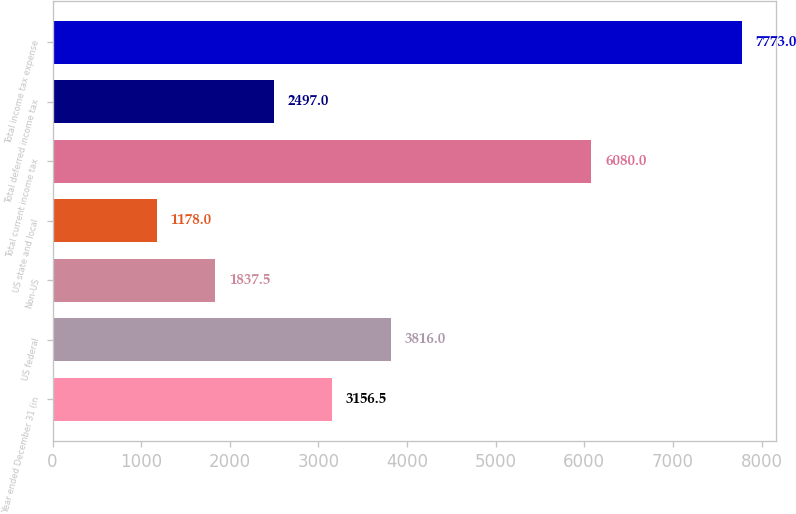<chart> <loc_0><loc_0><loc_500><loc_500><bar_chart><fcel>Year ended December 31 (in<fcel>US federal<fcel>Non-US<fcel>US state and local<fcel>Total current income tax<fcel>Total deferred income tax<fcel>Total income tax expense<nl><fcel>3156.5<fcel>3816<fcel>1837.5<fcel>1178<fcel>6080<fcel>2497<fcel>7773<nl></chart> 